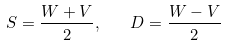Convert formula to latex. <formula><loc_0><loc_0><loc_500><loc_500>S = \frac { W + V } { 2 } , \quad D = \frac { W - V } { 2 }</formula> 